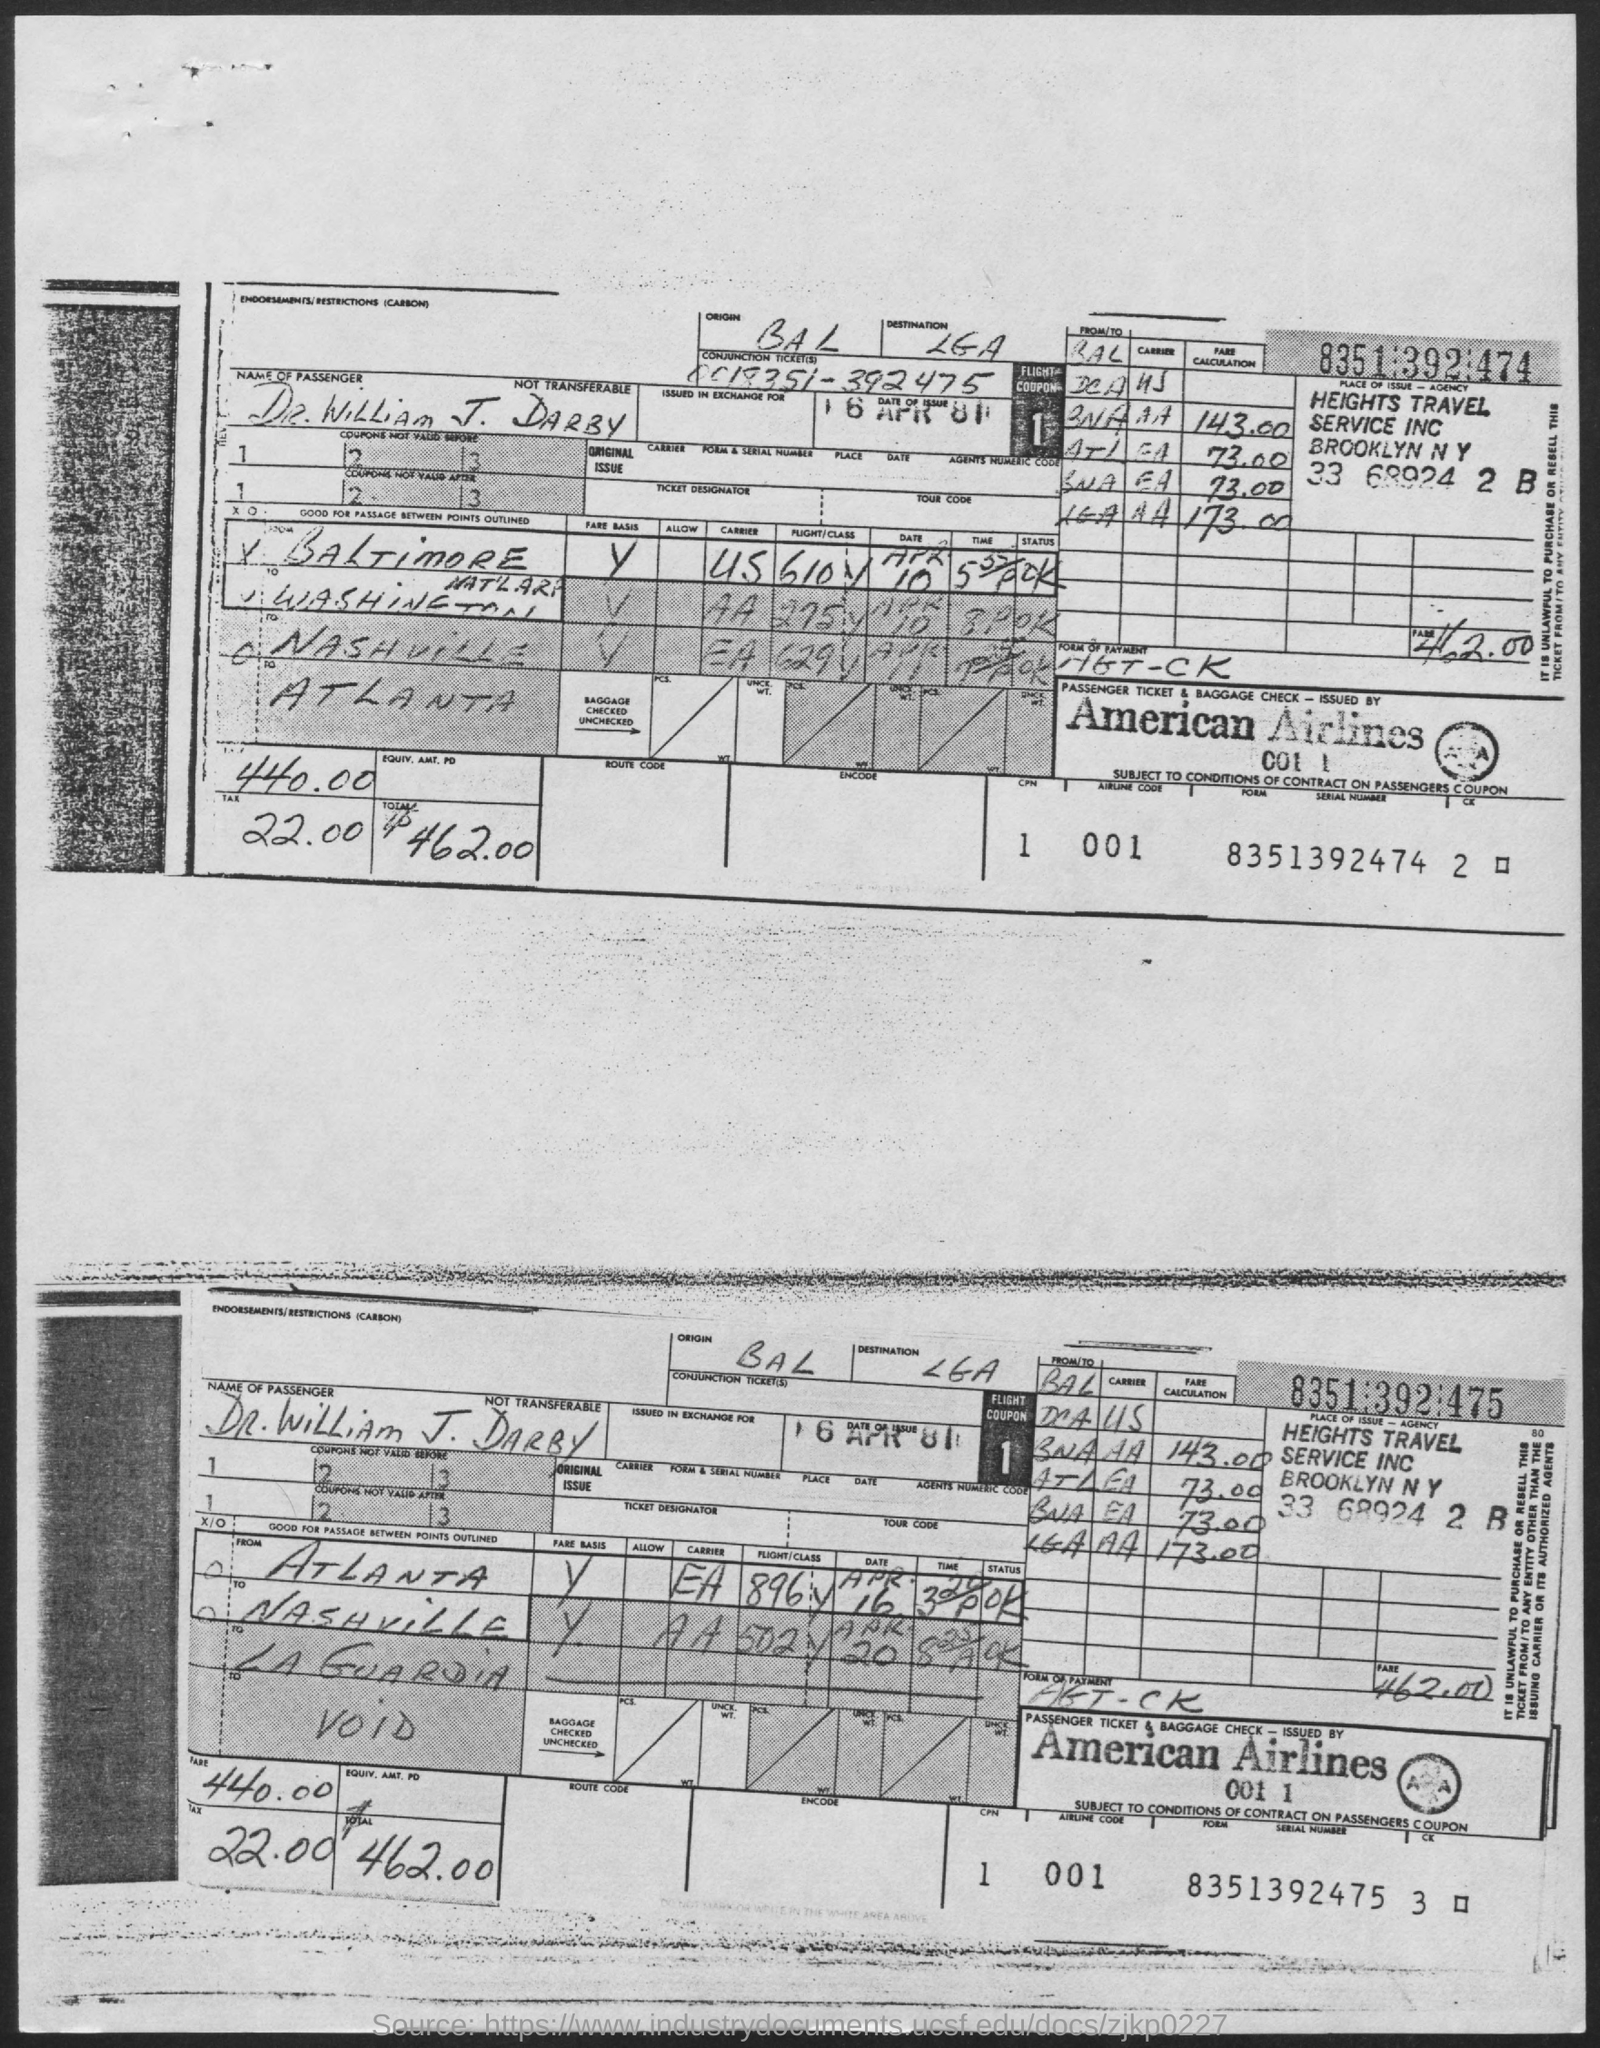Highlight a few significant elements in this photo. The total is 462.00, rounded to the nearest dollar. The fare is 440.00. The tax is 22.00... What is the origin of BAL? The destination is LaGuardia Airport. 